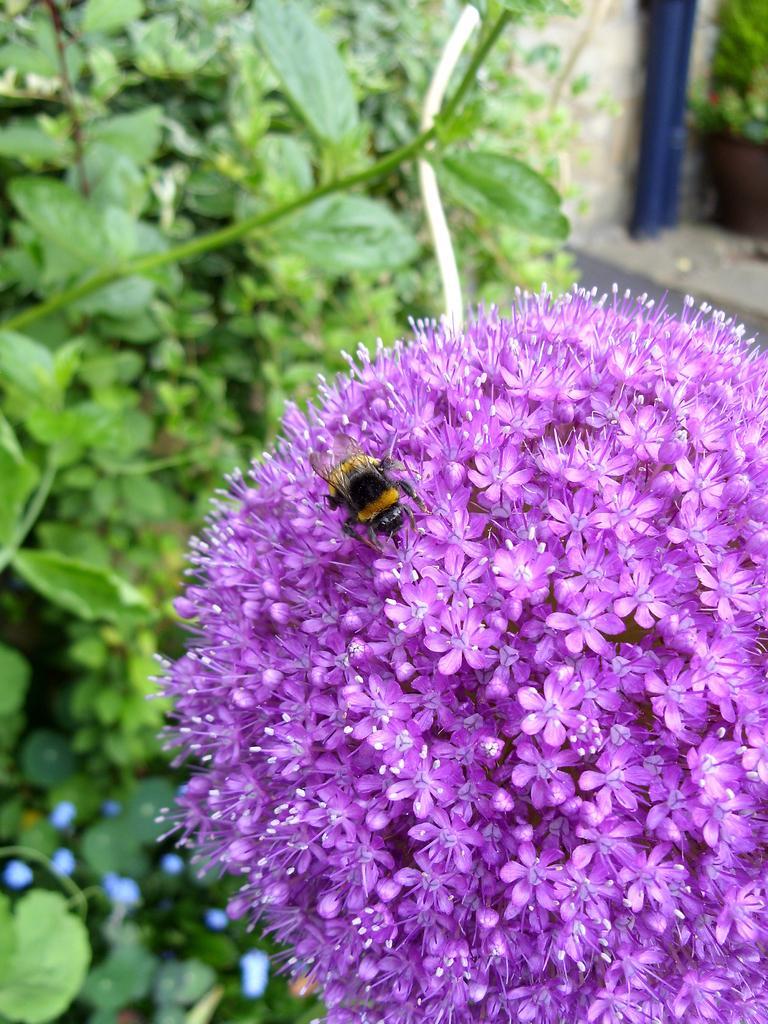Could you give a brief overview of what you see in this image? In this image there is a bunch of flower. On it there is a bee. Here there are plants. This is a wall. 